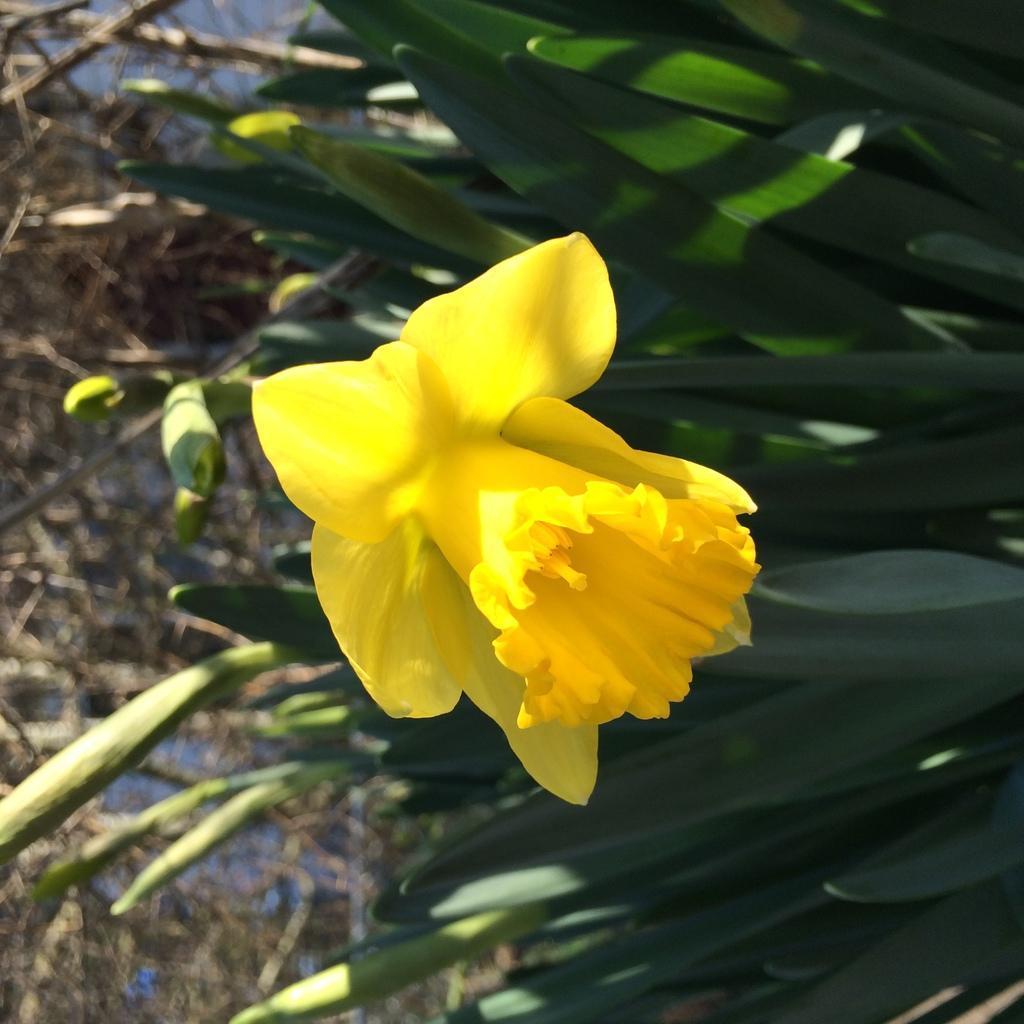Could you give a brief overview of what you see in this image? In this image, we can see a plant contains a flower. 